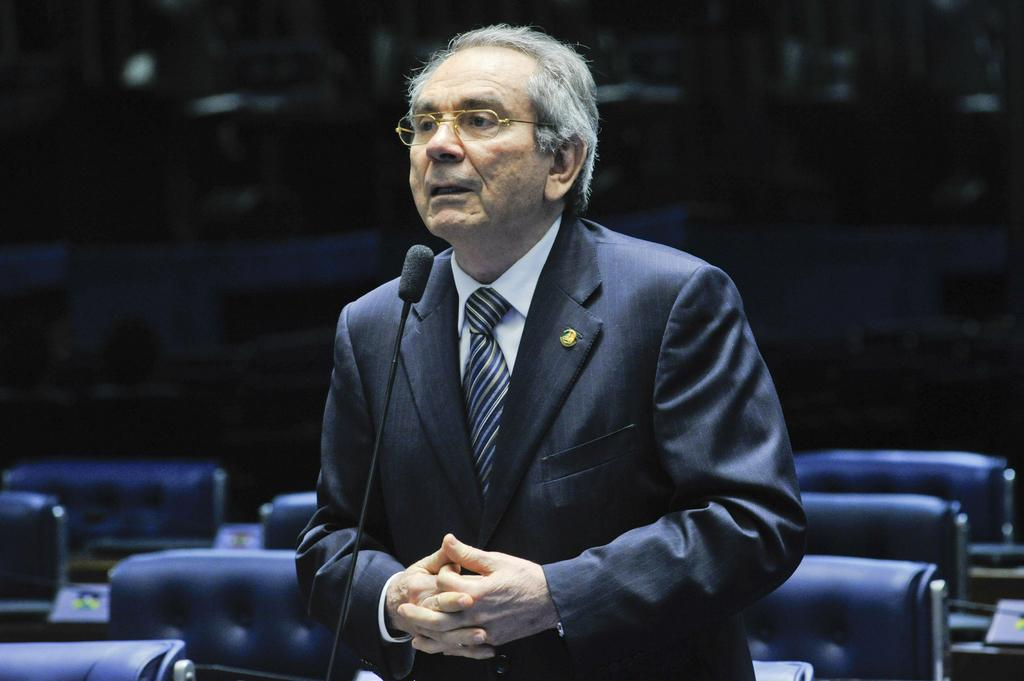Who is the main subject in the image? There is an old man in the image. What is the old man doing in the image? The old man is standing in front of a microphone. Who might the old man be addressing or speaking to? The old man is looking at someone, which suggests he might be addressing or speaking to them. What can be seen in the background of the image? There are chairs visible in the background of the image. What type of plant is growing on the old man's head in the image? There is no plant growing on the old man's head in the image. How does the old man's memory affect his speech in the image? The provided facts do not mention anything about the old man's memory, so it cannot be determined how his memory affects his speech in the image. 